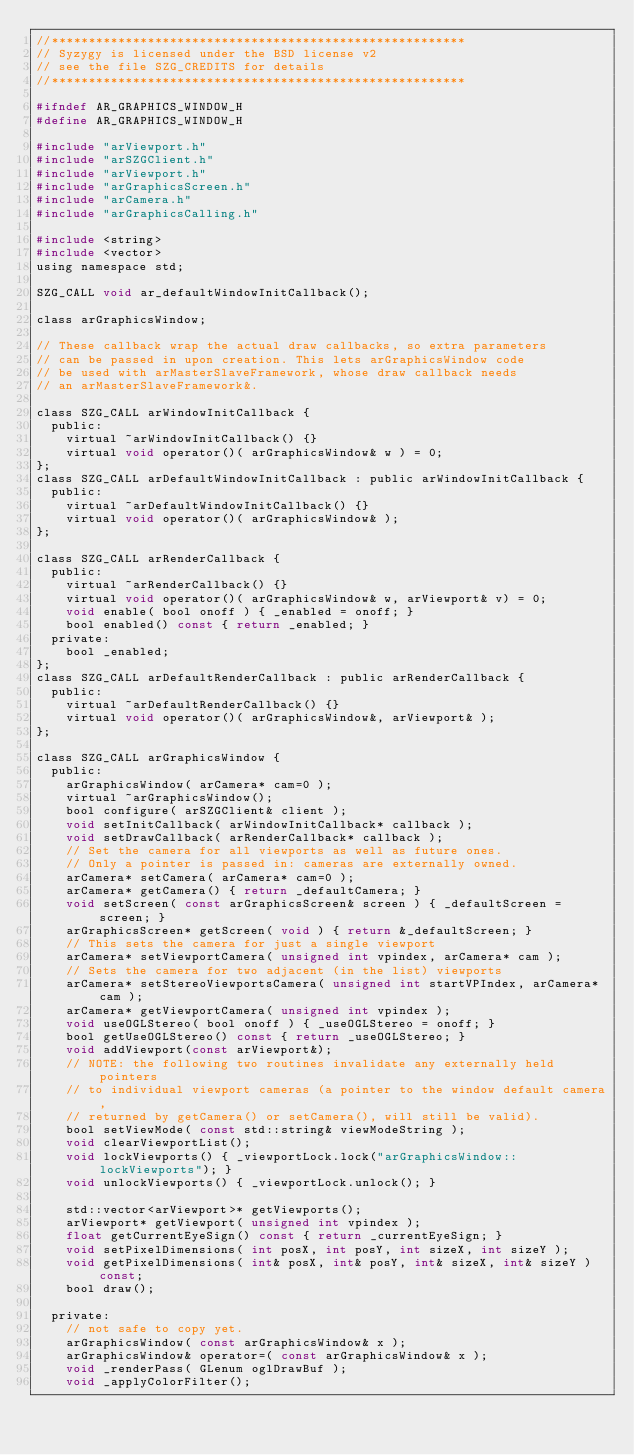<code> <loc_0><loc_0><loc_500><loc_500><_C_>//********************************************************
// Syzygy is licensed under the BSD license v2
// see the file SZG_CREDITS for details
//********************************************************

#ifndef AR_GRAPHICS_WINDOW_H
#define AR_GRAPHICS_WINDOW_H

#include "arViewport.h"
#include "arSZGClient.h"
#include "arViewport.h"
#include "arGraphicsScreen.h"
#include "arCamera.h"
#include "arGraphicsCalling.h"

#include <string>
#include <vector>
using namespace std;

SZG_CALL void ar_defaultWindowInitCallback();

class arGraphicsWindow;

// These callback wrap the actual draw callbacks, so extra parameters
// can be passed in upon creation. This lets arGraphicsWindow code
// be used with arMasterSlaveFramework, whose draw callback needs
// an arMasterSlaveFramework&.

class SZG_CALL arWindowInitCallback {
  public:
    virtual ~arWindowInitCallback() {}
    virtual void operator()( arGraphicsWindow& w ) = 0;
};
class SZG_CALL arDefaultWindowInitCallback : public arWindowInitCallback {
  public:
    virtual ~arDefaultWindowInitCallback() {}
    virtual void operator()( arGraphicsWindow& );
};

class SZG_CALL arRenderCallback {
  public:
    virtual ~arRenderCallback() {}
    virtual void operator()( arGraphicsWindow& w, arViewport& v) = 0;
    void enable( bool onoff ) { _enabled = onoff; }
    bool enabled() const { return _enabled; }
  private:
    bool _enabled;
};
class SZG_CALL arDefaultRenderCallback : public arRenderCallback {
  public:
    virtual ~arDefaultRenderCallback() {}
    virtual void operator()( arGraphicsWindow&, arViewport& );
};

class SZG_CALL arGraphicsWindow {
  public:
    arGraphicsWindow( arCamera* cam=0 );
    virtual ~arGraphicsWindow();
    bool configure( arSZGClient& client );
    void setInitCallback( arWindowInitCallback* callback );
    void setDrawCallback( arRenderCallback* callback );
    // Set the camera for all viewports as well as future ones.
    // Only a pointer is passed in: cameras are externally owned.
    arCamera* setCamera( arCamera* cam=0 );
    arCamera* getCamera() { return _defaultCamera; }
    void setScreen( const arGraphicsScreen& screen ) { _defaultScreen = screen; }
    arGraphicsScreen* getScreen( void ) { return &_defaultScreen; }
    // This sets the camera for just a single viewport
    arCamera* setViewportCamera( unsigned int vpindex, arCamera* cam );
    // Sets the camera for two adjacent (in the list) viewports
    arCamera* setStereoViewportsCamera( unsigned int startVPIndex, arCamera* cam );
    arCamera* getViewportCamera( unsigned int vpindex );
    void useOGLStereo( bool onoff ) { _useOGLStereo = onoff; }
    bool getUseOGLStereo() const { return _useOGLStereo; }
    void addViewport(const arViewport&);
    // NOTE: the following two routines invalidate any externally held pointers
    // to individual viewport cameras (a pointer to the window default camera,
    // returned by getCamera() or setCamera(), will still be valid).
    bool setViewMode( const std::string& viewModeString );
    void clearViewportList();
    void lockViewports() { _viewportLock.lock("arGraphicsWindow::lockViewports"); }
    void unlockViewports() { _viewportLock.unlock(); }

    std::vector<arViewport>* getViewports();
    arViewport* getViewport( unsigned int vpindex );
    float getCurrentEyeSign() const { return _currentEyeSign; }
    void setPixelDimensions( int posX, int posY, int sizeX, int sizeY );
    void getPixelDimensions( int& posX, int& posY, int& sizeX, int& sizeY ) const;
    bool draw();

  private:
    // not safe to copy yet.
    arGraphicsWindow( const arGraphicsWindow& x );
    arGraphicsWindow& operator=( const arGraphicsWindow& x );
    void _renderPass( GLenum oglDrawBuf );
    void _applyColorFilter();</code> 